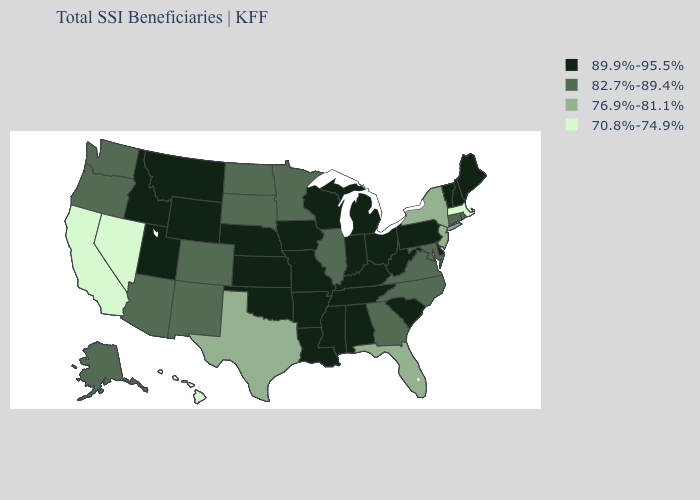What is the value of Michigan?
Be succinct. 89.9%-95.5%. What is the value of Colorado?
Be succinct. 82.7%-89.4%. Does the first symbol in the legend represent the smallest category?
Concise answer only. No. What is the value of Vermont?
Concise answer only. 89.9%-95.5%. Among the states that border Colorado , does Nebraska have the highest value?
Keep it brief. Yes. Does Minnesota have the lowest value in the MidWest?
Short answer required. Yes. How many symbols are there in the legend?
Concise answer only. 4. Among the states that border Alabama , which have the highest value?
Concise answer only. Mississippi, Tennessee. What is the value of Tennessee?
Answer briefly. 89.9%-95.5%. Among the states that border Mississippi , which have the highest value?
Be succinct. Alabama, Arkansas, Louisiana, Tennessee. What is the highest value in the USA?
Answer briefly. 89.9%-95.5%. What is the value of Idaho?
Quick response, please. 89.9%-95.5%. Does California have the lowest value in the USA?
Answer briefly. Yes. What is the highest value in states that border Nevada?
Answer briefly. 89.9%-95.5%. Name the states that have a value in the range 70.8%-74.9%?
Concise answer only. California, Hawaii, Massachusetts, Nevada. 